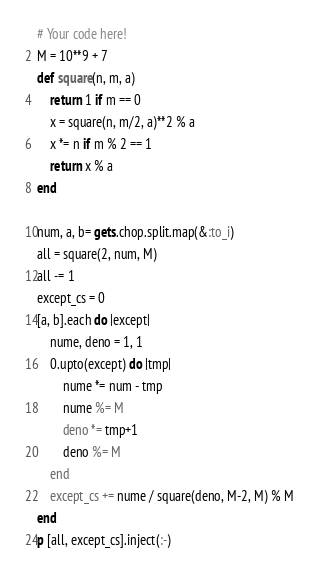Convert code to text. <code><loc_0><loc_0><loc_500><loc_500><_Ruby_># Your code here!
M = 10**9 + 7
def square(n, m, a)
    return 1 if m == 0
    x = square(n, m/2, a)**2 % a
    x *= n if m % 2 == 1
    return x % a
end

num, a, b= gets.chop.split.map(&:to_i)
all = square(2, num, M)
all -= 1
except_cs = 0
[a, b].each do |except|
    nume, deno = 1, 1
    0.upto(except) do |tmp|
        nume *= num - tmp
        nume %= M
        deno *= tmp+1
        deno %= M
    end
    except_cs += nume / square(deno, M-2, M) % M
end
p [all, except_cs].inject(:-)</code> 